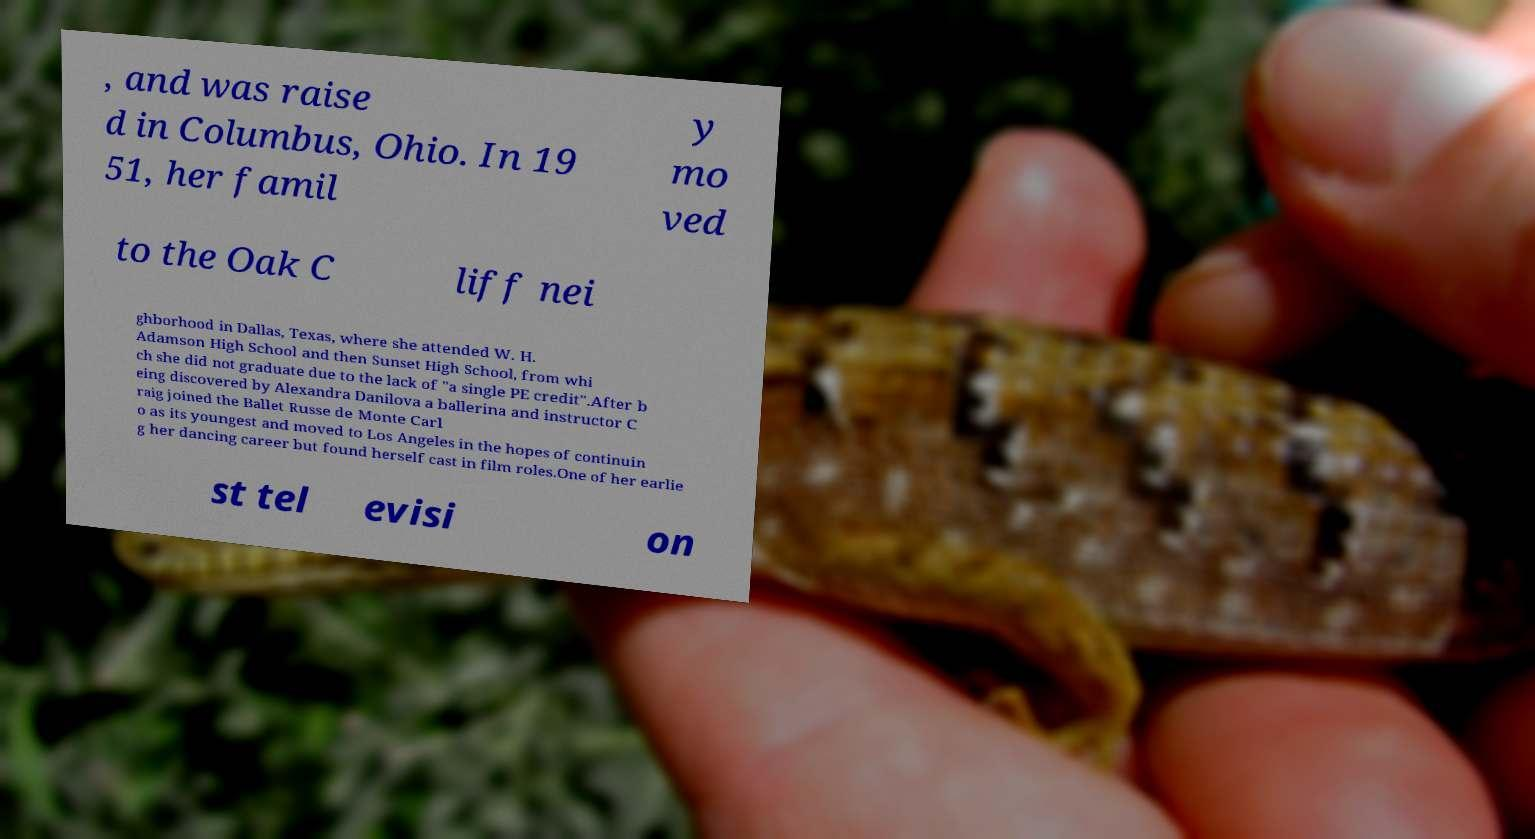For documentation purposes, I need the text within this image transcribed. Could you provide that? , and was raise d in Columbus, Ohio. In 19 51, her famil y mo ved to the Oak C liff nei ghborhood in Dallas, Texas, where she attended W. H. Adamson High School and then Sunset High School, from whi ch she did not graduate due to the lack of "a single PE credit".After b eing discovered by Alexandra Danilova a ballerina and instructor C raig joined the Ballet Russe de Monte Carl o as its youngest and moved to Los Angeles in the hopes of continuin g her dancing career but found herself cast in film roles.One of her earlie st tel evisi on 